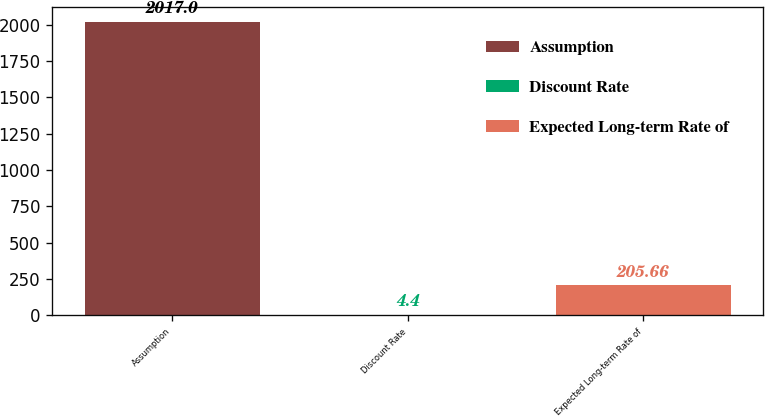Convert chart to OTSL. <chart><loc_0><loc_0><loc_500><loc_500><bar_chart><fcel>Assumption<fcel>Discount Rate<fcel>Expected Long-term Rate of<nl><fcel>2017<fcel>4.4<fcel>205.66<nl></chart> 